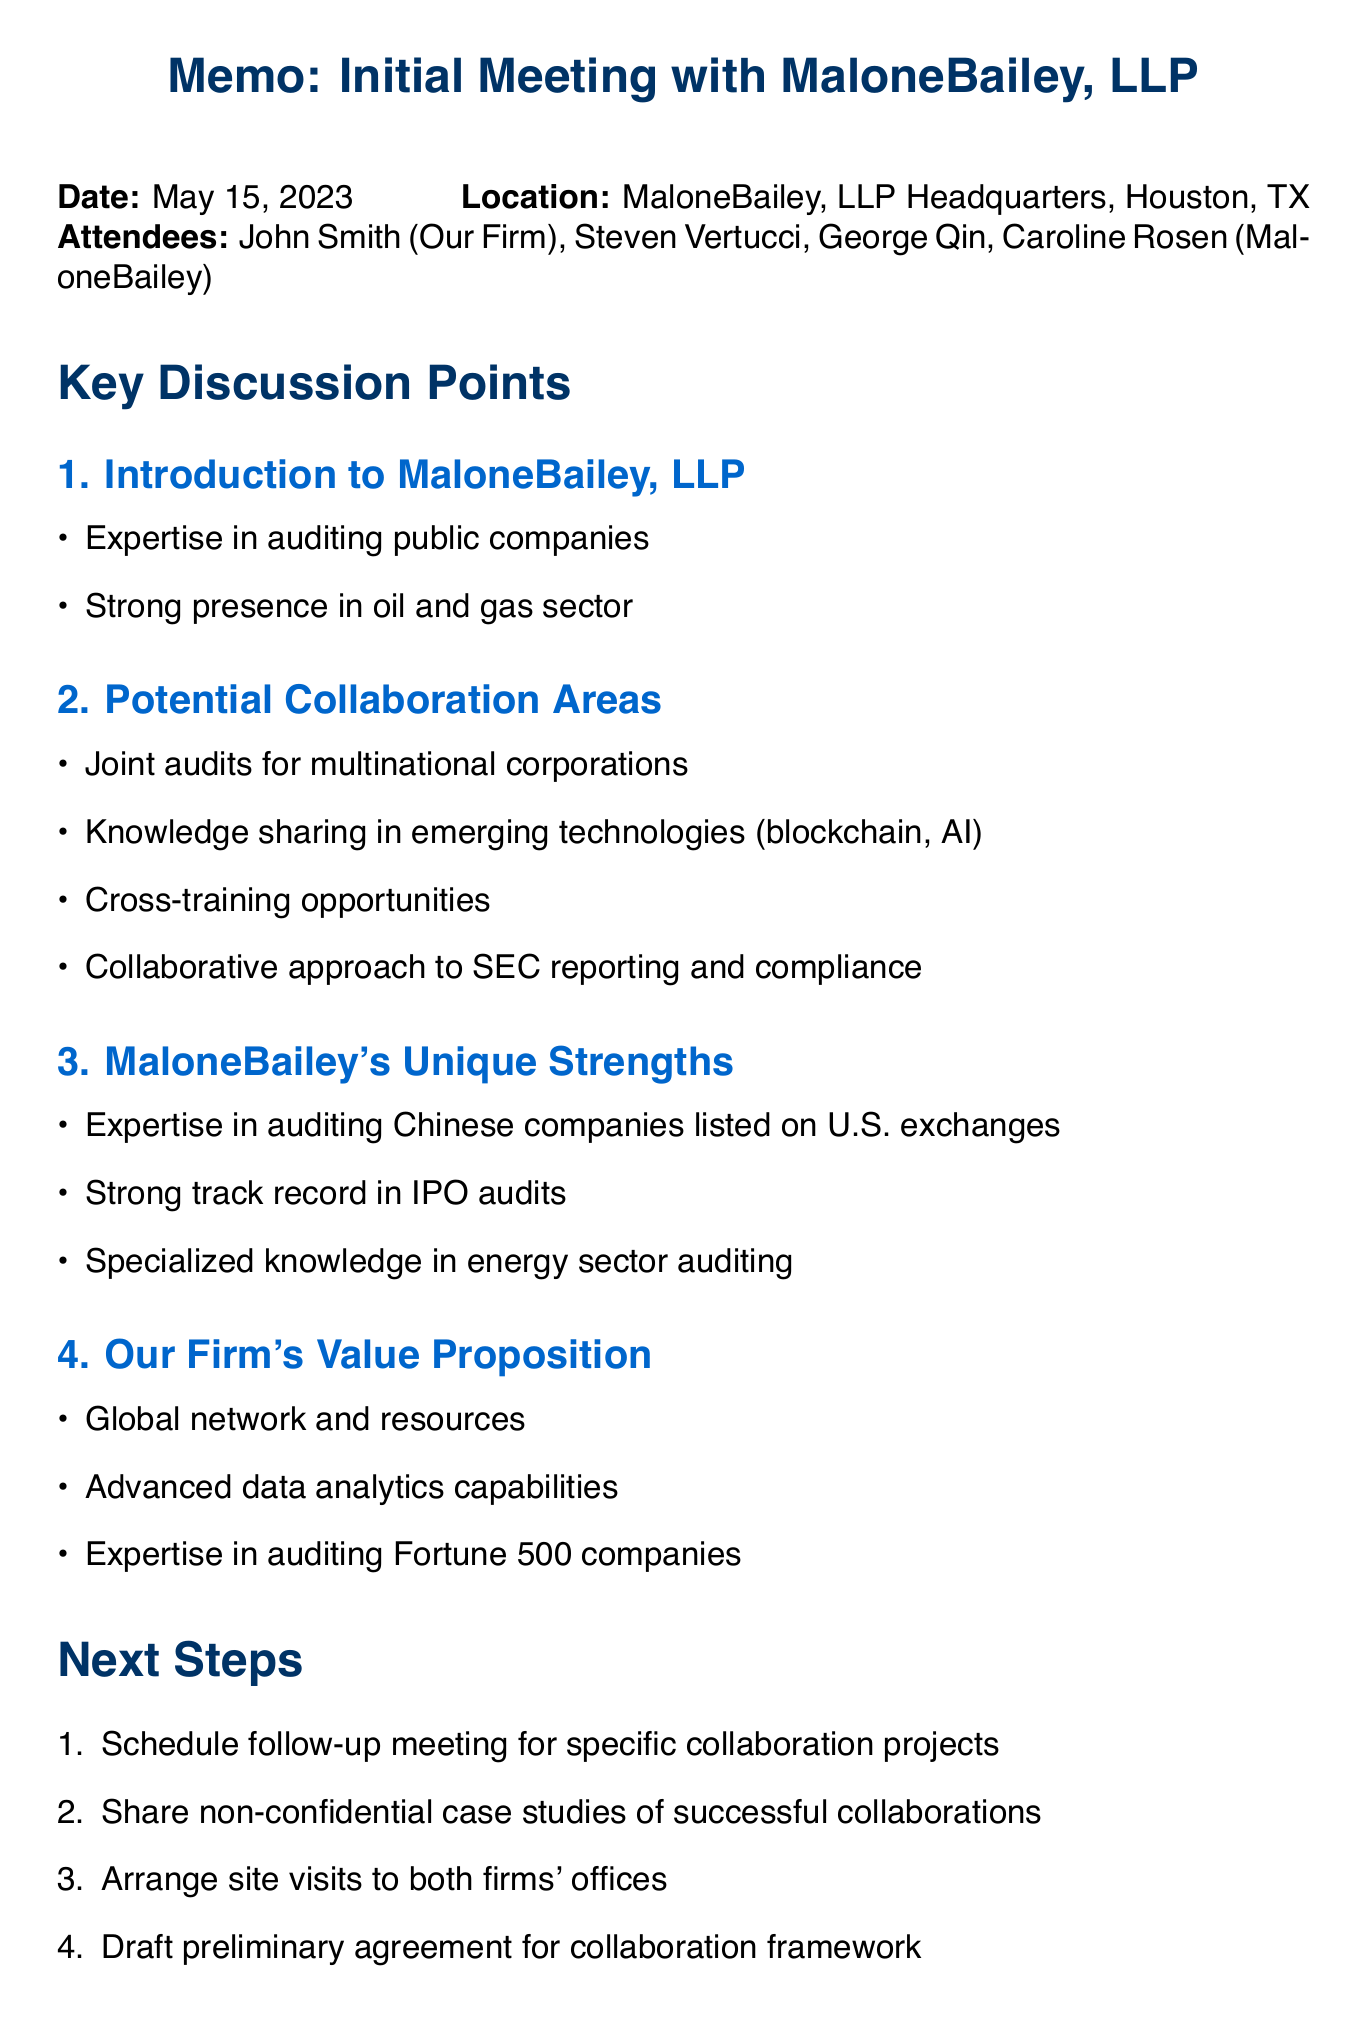What is the date of the meeting? The date of the meeting is explicitly mentioned in the memo.
Answer: May 15, 2023 Who represented our firm in the meeting? The memo lists the attendees, including the representative from our firm.
Answer: John Smith What is one potential collaboration area discussed? The memo provides a list of potential collaboration areas discussed during the meeting.
Answer: Joint audits for multinational corporations What is MaloneBailey's unique strength? The document highlights MaloneBailey's unique strengths in the context of their expertise.
Answer: Expertise in auditing Chinese companies listed on U.S. exchanges What is one of our firm's value propositions? The memo outlines our firm's key value propositions during the discussion.
Answer: Global network and resources What is the next step after the meeting? The document lists the next steps following the meeting.
Answer: Schedule follow-up meeting to discuss specific collaboration projects What are potential challenges mentioned? The memo details specific challenges related to collaboration that were identified in the discussion.
Answer: Aligning quality control standards What type of companies is MaloneBailey particularly strong in auditing? The document specifies the area in which MaloneBailey has strong expertise.
Answer: Oil and gas sector What kind of case studies are to be shared? The next steps include sharing specific types of case studies.
Answer: Non-confidential case studies of successful collaborations 